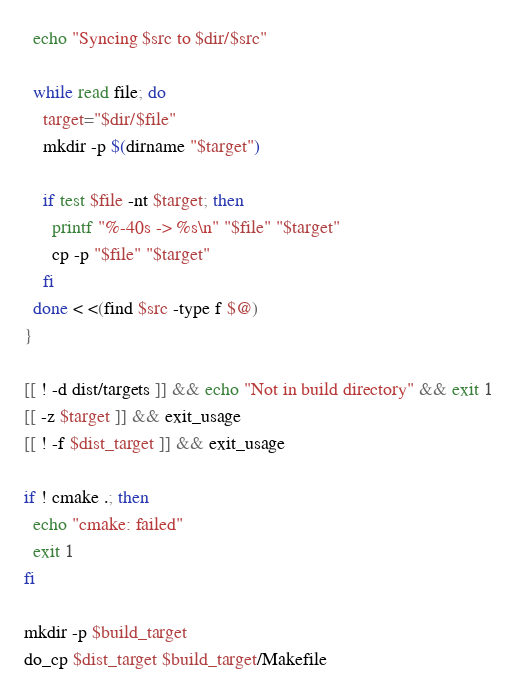Convert code to text. <code><loc_0><loc_0><loc_500><loc_500><_Bash_>
  echo "Syncing $src to $dir/$src"

  while read file; do
    target="$dir/$file"
    mkdir -p $(dirname "$target")

    if test $file -nt $target; then
      printf "%-40s -> %s\n" "$file" "$target"
      cp -p "$file" "$target"
    fi
  done < <(find $src -type f $@)
}

[[ ! -d dist/targets ]] && echo "Not in build directory" && exit 1
[[ -z $target ]] && exit_usage
[[ ! -f $dist_target ]] && exit_usage

if ! cmake .; then
  echo "cmake: failed"
  exit 1
fi

mkdir -p $build_target
do_cp $dist_target $build_target/Makefile</code> 